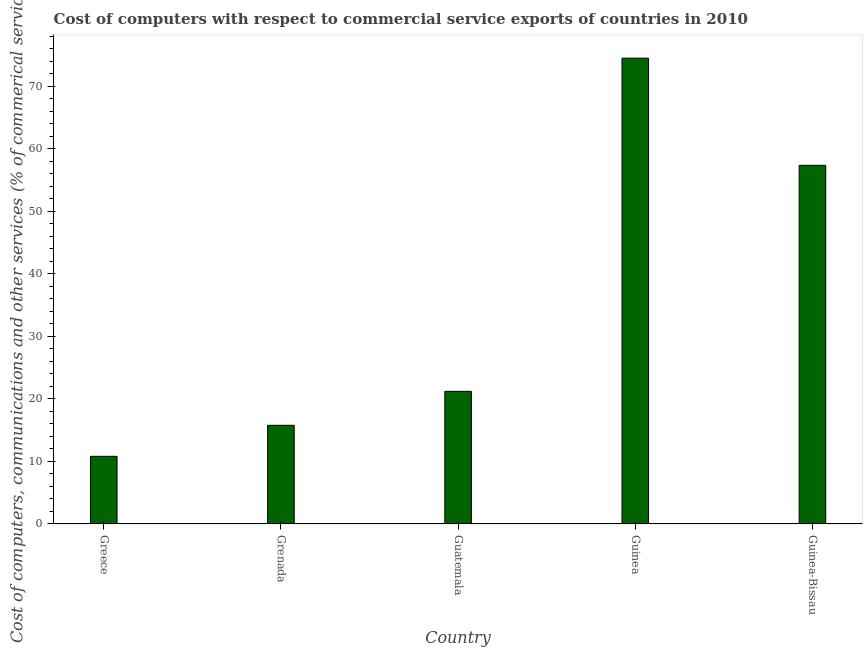What is the title of the graph?
Your answer should be very brief. Cost of computers with respect to commercial service exports of countries in 2010. What is the label or title of the X-axis?
Give a very brief answer. Country. What is the label or title of the Y-axis?
Ensure brevity in your answer.  Cost of computers, communications and other services (% of commerical service exports). What is the cost of communications in Guatemala?
Keep it short and to the point. 21.21. Across all countries, what is the maximum cost of communications?
Provide a succinct answer. 74.5. Across all countries, what is the minimum cost of communications?
Offer a very short reply. 10.82. In which country was the cost of communications maximum?
Your answer should be compact. Guinea. In which country was the  computer and other services minimum?
Your answer should be very brief. Greece. What is the sum of the  computer and other services?
Provide a short and direct response. 179.67. What is the difference between the  computer and other services in Grenada and Guinea-Bissau?
Offer a very short reply. -41.58. What is the average  computer and other services per country?
Provide a short and direct response. 35.93. What is the median cost of communications?
Provide a succinct answer. 21.21. What is the ratio of the  computer and other services in Guatemala to that in Guinea-Bissau?
Keep it short and to the point. 0.37. Is the  computer and other services in Greece less than that in Guinea?
Make the answer very short. Yes. Is the difference between the cost of communications in Greece and Guinea greater than the difference between any two countries?
Offer a terse response. Yes. What is the difference between the highest and the second highest cost of communications?
Ensure brevity in your answer.  17.14. What is the difference between the highest and the lowest cost of communications?
Give a very brief answer. 63.68. How many bars are there?
Your answer should be compact. 5. Are all the bars in the graph horizontal?
Ensure brevity in your answer.  No. What is the difference between two consecutive major ticks on the Y-axis?
Offer a terse response. 10. What is the Cost of computers, communications and other services (% of commerical service exports) in Greece?
Give a very brief answer. 10.82. What is the Cost of computers, communications and other services (% of commerical service exports) of Grenada?
Ensure brevity in your answer.  15.78. What is the Cost of computers, communications and other services (% of commerical service exports) in Guatemala?
Make the answer very short. 21.21. What is the Cost of computers, communications and other services (% of commerical service exports) of Guinea?
Your answer should be compact. 74.5. What is the Cost of computers, communications and other services (% of commerical service exports) in Guinea-Bissau?
Your answer should be compact. 57.36. What is the difference between the Cost of computers, communications and other services (% of commerical service exports) in Greece and Grenada?
Offer a terse response. -4.96. What is the difference between the Cost of computers, communications and other services (% of commerical service exports) in Greece and Guatemala?
Make the answer very short. -10.39. What is the difference between the Cost of computers, communications and other services (% of commerical service exports) in Greece and Guinea?
Your answer should be very brief. -63.68. What is the difference between the Cost of computers, communications and other services (% of commerical service exports) in Greece and Guinea-Bissau?
Give a very brief answer. -46.54. What is the difference between the Cost of computers, communications and other services (% of commerical service exports) in Grenada and Guatemala?
Make the answer very short. -5.43. What is the difference between the Cost of computers, communications and other services (% of commerical service exports) in Grenada and Guinea?
Your answer should be very brief. -58.72. What is the difference between the Cost of computers, communications and other services (% of commerical service exports) in Grenada and Guinea-Bissau?
Keep it short and to the point. -41.58. What is the difference between the Cost of computers, communications and other services (% of commerical service exports) in Guatemala and Guinea?
Your response must be concise. -53.29. What is the difference between the Cost of computers, communications and other services (% of commerical service exports) in Guatemala and Guinea-Bissau?
Ensure brevity in your answer.  -36.15. What is the difference between the Cost of computers, communications and other services (% of commerical service exports) in Guinea and Guinea-Bissau?
Your answer should be very brief. 17.14. What is the ratio of the Cost of computers, communications and other services (% of commerical service exports) in Greece to that in Grenada?
Provide a succinct answer. 0.69. What is the ratio of the Cost of computers, communications and other services (% of commerical service exports) in Greece to that in Guatemala?
Your answer should be very brief. 0.51. What is the ratio of the Cost of computers, communications and other services (% of commerical service exports) in Greece to that in Guinea?
Your response must be concise. 0.14. What is the ratio of the Cost of computers, communications and other services (% of commerical service exports) in Greece to that in Guinea-Bissau?
Your answer should be very brief. 0.19. What is the ratio of the Cost of computers, communications and other services (% of commerical service exports) in Grenada to that in Guatemala?
Your response must be concise. 0.74. What is the ratio of the Cost of computers, communications and other services (% of commerical service exports) in Grenada to that in Guinea?
Your response must be concise. 0.21. What is the ratio of the Cost of computers, communications and other services (% of commerical service exports) in Grenada to that in Guinea-Bissau?
Ensure brevity in your answer.  0.28. What is the ratio of the Cost of computers, communications and other services (% of commerical service exports) in Guatemala to that in Guinea?
Provide a succinct answer. 0.28. What is the ratio of the Cost of computers, communications and other services (% of commerical service exports) in Guatemala to that in Guinea-Bissau?
Offer a very short reply. 0.37. What is the ratio of the Cost of computers, communications and other services (% of commerical service exports) in Guinea to that in Guinea-Bissau?
Provide a short and direct response. 1.3. 